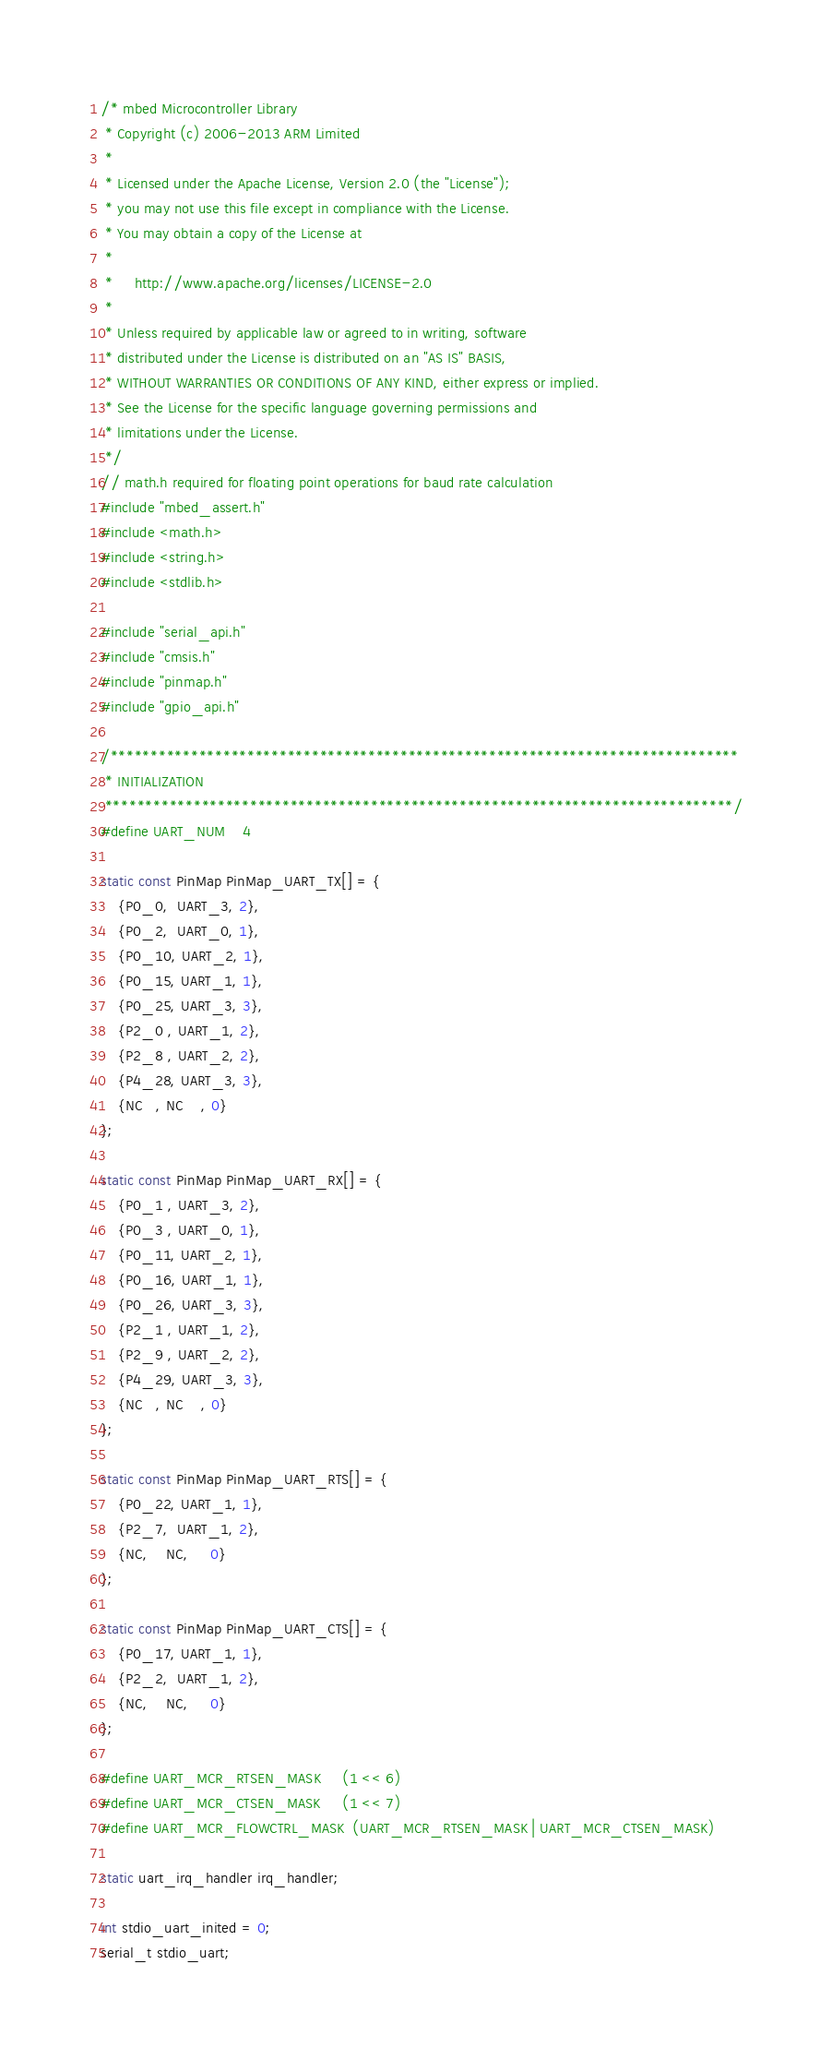<code> <loc_0><loc_0><loc_500><loc_500><_C_>/* mbed Microcontroller Library
 * Copyright (c) 2006-2013 ARM Limited
 *
 * Licensed under the Apache License, Version 2.0 (the "License");
 * you may not use this file except in compliance with the License.
 * You may obtain a copy of the License at
 *
 *     http://www.apache.org/licenses/LICENSE-2.0
 *
 * Unless required by applicable law or agreed to in writing, software
 * distributed under the License is distributed on an "AS IS" BASIS,
 * WITHOUT WARRANTIES OR CONDITIONS OF ANY KIND, either express or implied.
 * See the License for the specific language governing permissions and
 * limitations under the License.
 */
// math.h required for floating point operations for baud rate calculation
#include "mbed_assert.h"
#include <math.h>
#include <string.h>
#include <stdlib.h>

#include "serial_api.h"
#include "cmsis.h"
#include "pinmap.h"
#include "gpio_api.h"

/******************************************************************************
 * INITIALIZATION
 ******************************************************************************/
#define UART_NUM    4

static const PinMap PinMap_UART_TX[] = {
    {P0_0,  UART_3, 2},
    {P0_2,  UART_0, 1},
    {P0_10, UART_2, 1},
    {P0_15, UART_1, 1},
    {P0_25, UART_3, 3},
    {P2_0 , UART_1, 2},
    {P2_8 , UART_2, 2},
    {P4_28, UART_3, 3},
    {NC   , NC    , 0}
};

static const PinMap PinMap_UART_RX[] = {
    {P0_1 , UART_3, 2},
    {P0_3 , UART_0, 1},
    {P0_11, UART_2, 1},
    {P0_16, UART_1, 1},
    {P0_26, UART_3, 3},
    {P2_1 , UART_1, 2},
    {P2_9 , UART_2, 2},
    {P4_29, UART_3, 3},
    {NC   , NC    , 0}
};

static const PinMap PinMap_UART_RTS[] = {
    {P0_22, UART_1, 1},
    {P2_7,  UART_1, 2},
    {NC,    NC,     0}
};

static const PinMap PinMap_UART_CTS[] = {
    {P0_17, UART_1, 1},
    {P2_2,  UART_1, 2},
    {NC,    NC,     0}
};

#define UART_MCR_RTSEN_MASK     (1 << 6)
#define UART_MCR_CTSEN_MASK     (1 << 7)
#define UART_MCR_FLOWCTRL_MASK  (UART_MCR_RTSEN_MASK | UART_MCR_CTSEN_MASK)

static uart_irq_handler irq_handler;

int stdio_uart_inited = 0;
serial_t stdio_uart;
</code> 